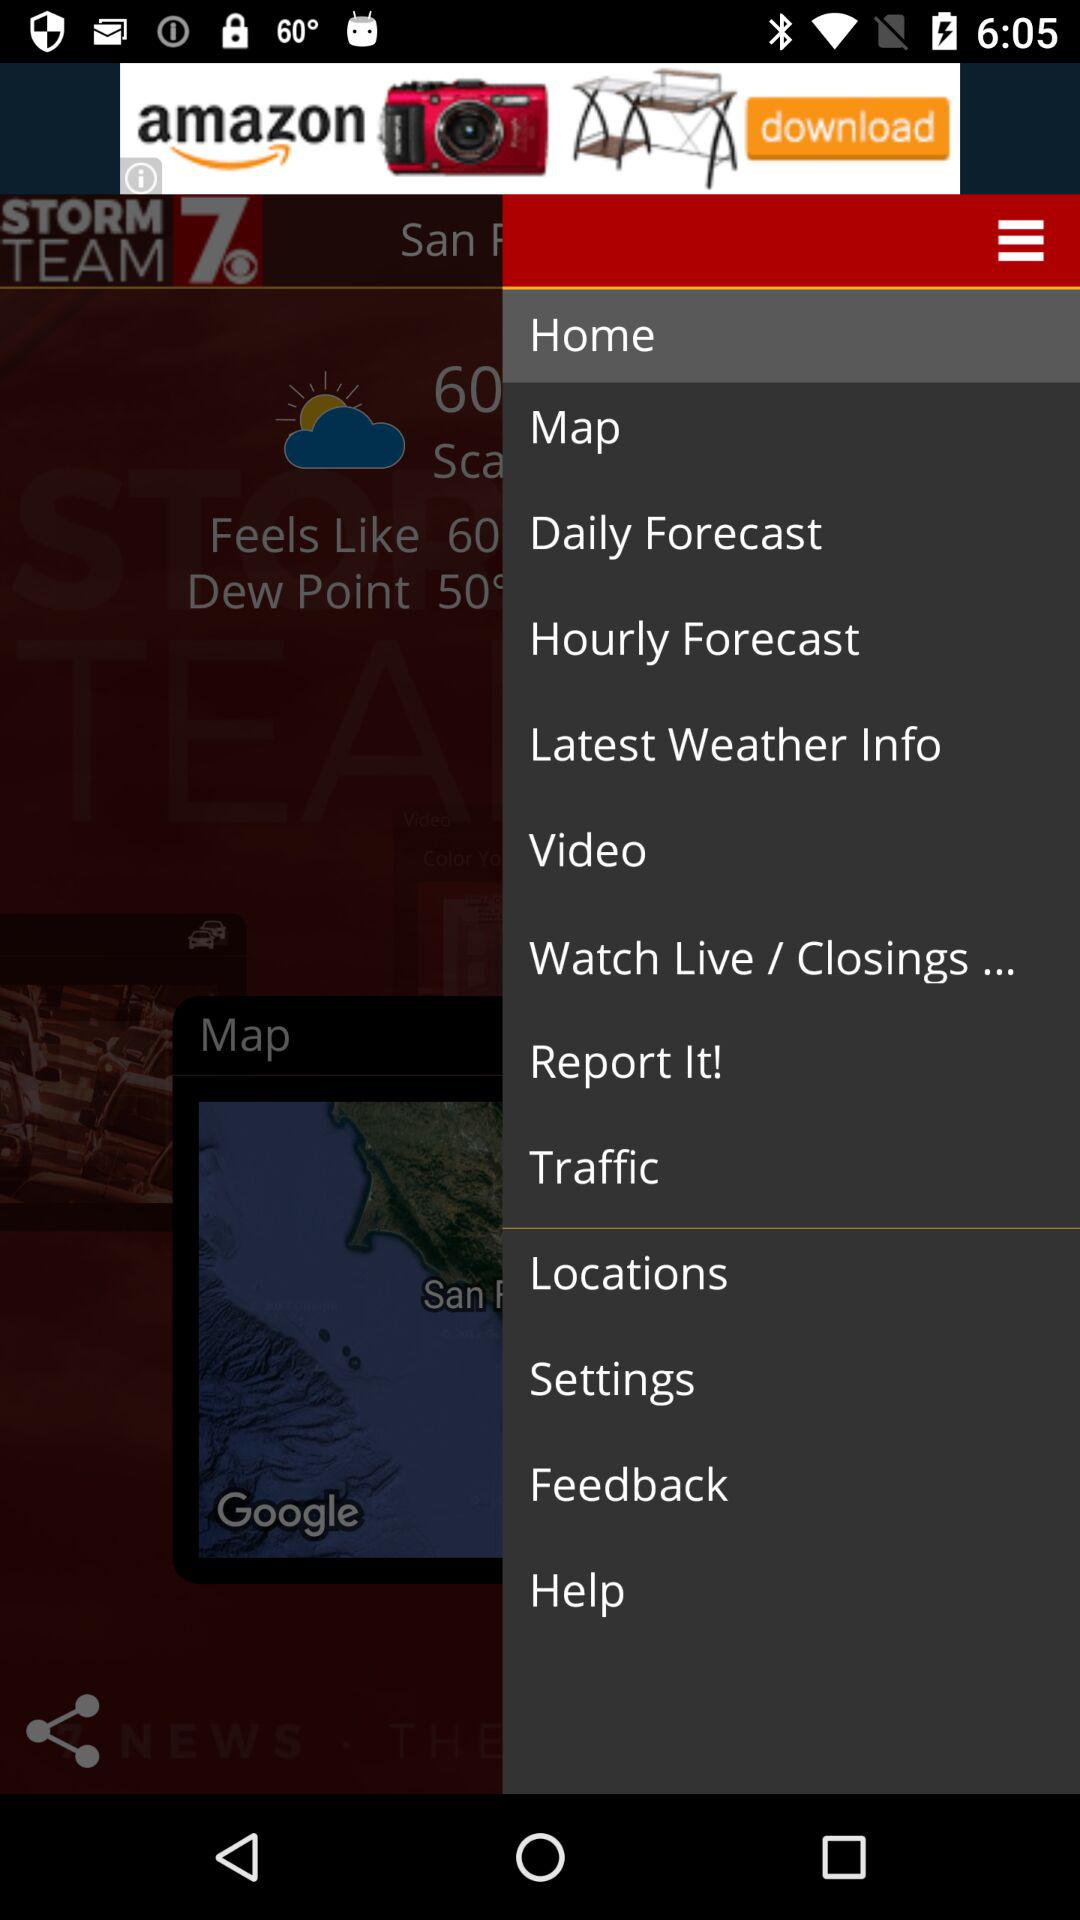How many more degrees Fahrenheit is the temperature than the dew point?
Answer the question using a single word or phrase. 10 